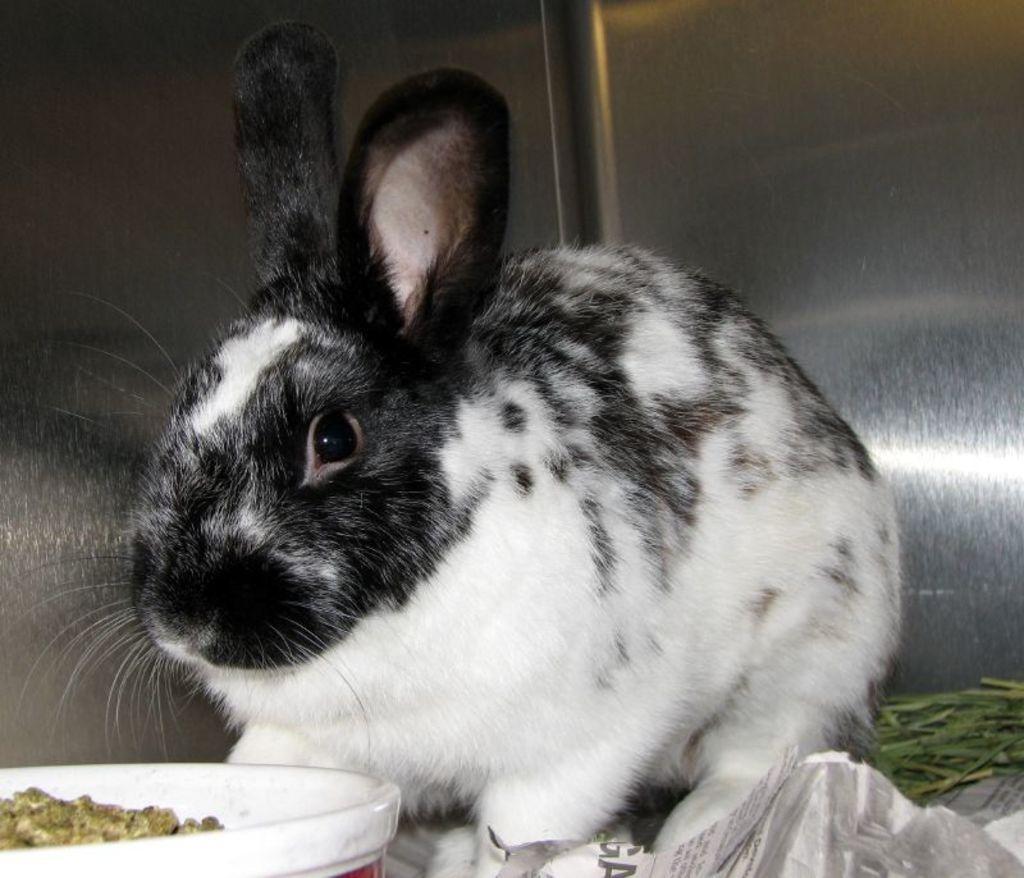In one or two sentences, can you explain what this image depicts? In this image there is a rabbit on the floor having some grass, paper and a bowl. There is some food in the bowl. Right side there is some grass. Background there is a wall. 